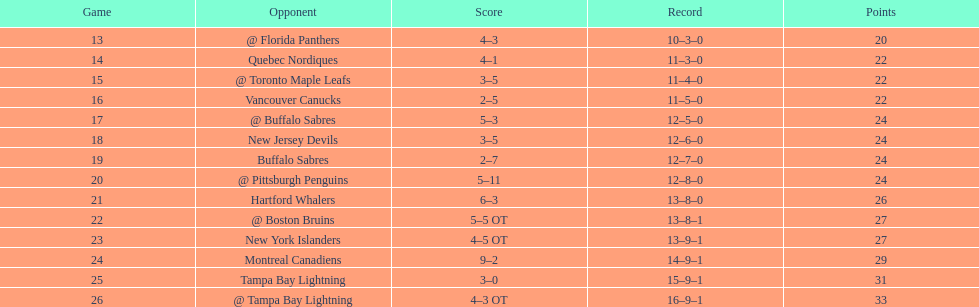What was the number of wins the philadelphia flyers had? 35. 